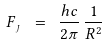<formula> <loc_0><loc_0><loc_500><loc_500>F _ { \, _ { J } } \ = \ \frac { h c } { 2 \pi } \, \frac { 1 } { R ^ { 2 } }</formula> 